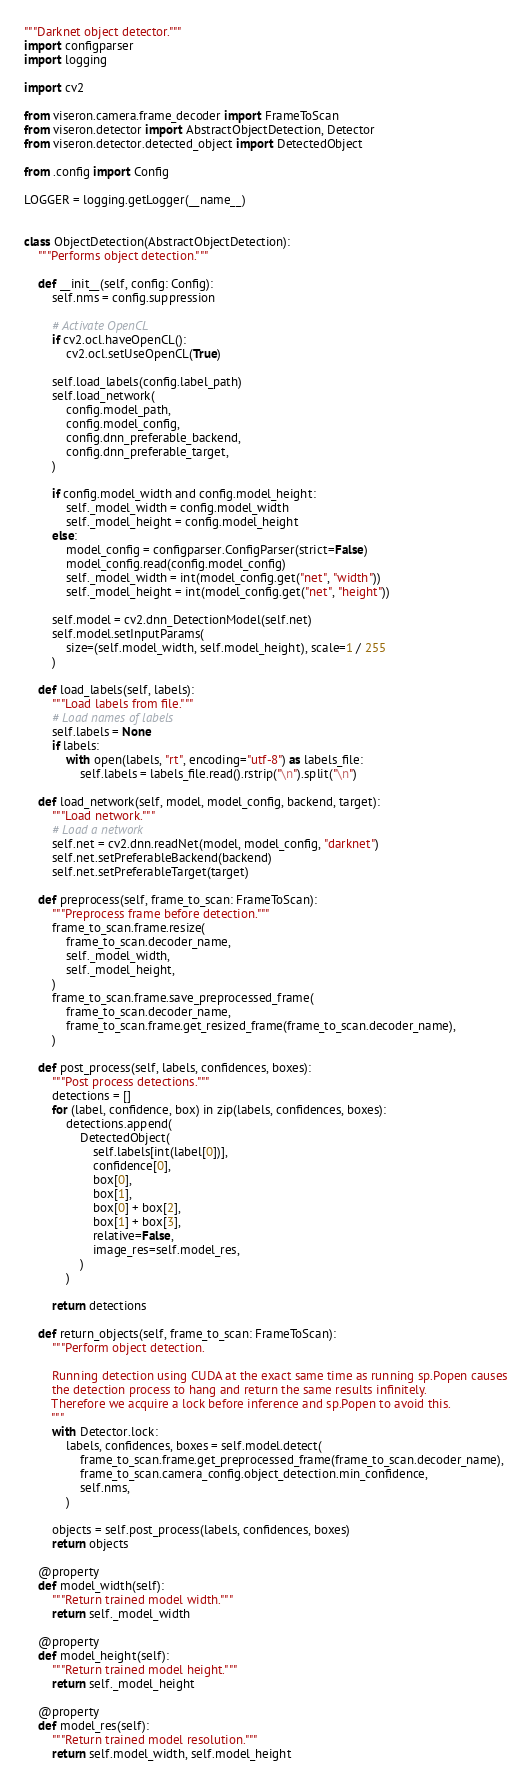Convert code to text. <code><loc_0><loc_0><loc_500><loc_500><_Python_>"""Darknet object detector."""
import configparser
import logging

import cv2

from viseron.camera.frame_decoder import FrameToScan
from viseron.detector import AbstractObjectDetection, Detector
from viseron.detector.detected_object import DetectedObject

from .config import Config

LOGGER = logging.getLogger(__name__)


class ObjectDetection(AbstractObjectDetection):
    """Performs object detection."""

    def __init__(self, config: Config):
        self.nms = config.suppression

        # Activate OpenCL
        if cv2.ocl.haveOpenCL():
            cv2.ocl.setUseOpenCL(True)

        self.load_labels(config.label_path)
        self.load_network(
            config.model_path,
            config.model_config,
            config.dnn_preferable_backend,
            config.dnn_preferable_target,
        )

        if config.model_width and config.model_height:
            self._model_width = config.model_width
            self._model_height = config.model_height
        else:
            model_config = configparser.ConfigParser(strict=False)
            model_config.read(config.model_config)
            self._model_width = int(model_config.get("net", "width"))
            self._model_height = int(model_config.get("net", "height"))

        self.model = cv2.dnn_DetectionModel(self.net)
        self.model.setInputParams(
            size=(self.model_width, self.model_height), scale=1 / 255
        )

    def load_labels(self, labels):
        """Load labels from file."""
        # Load names of labels
        self.labels = None
        if labels:
            with open(labels, "rt", encoding="utf-8") as labels_file:
                self.labels = labels_file.read().rstrip("\n").split("\n")

    def load_network(self, model, model_config, backend, target):
        """Load network."""
        # Load a network
        self.net = cv2.dnn.readNet(model, model_config, "darknet")
        self.net.setPreferableBackend(backend)
        self.net.setPreferableTarget(target)

    def preprocess(self, frame_to_scan: FrameToScan):
        """Preprocess frame before detection."""
        frame_to_scan.frame.resize(
            frame_to_scan.decoder_name,
            self._model_width,
            self._model_height,
        )
        frame_to_scan.frame.save_preprocessed_frame(
            frame_to_scan.decoder_name,
            frame_to_scan.frame.get_resized_frame(frame_to_scan.decoder_name),
        )

    def post_process(self, labels, confidences, boxes):
        """Post process detections."""
        detections = []
        for (label, confidence, box) in zip(labels, confidences, boxes):
            detections.append(
                DetectedObject(
                    self.labels[int(label[0])],
                    confidence[0],
                    box[0],
                    box[1],
                    box[0] + box[2],
                    box[1] + box[3],
                    relative=False,
                    image_res=self.model_res,
                )
            )

        return detections

    def return_objects(self, frame_to_scan: FrameToScan):
        """Perform object detection.

        Running detection using CUDA at the exact same time as running sp.Popen causes
        the detection process to hang and return the same results infinitely.
        Therefore we acquire a lock before inference and sp.Popen to avoid this.
        """
        with Detector.lock:
            labels, confidences, boxes = self.model.detect(
                frame_to_scan.frame.get_preprocessed_frame(frame_to_scan.decoder_name),
                frame_to_scan.camera_config.object_detection.min_confidence,
                self.nms,
            )

        objects = self.post_process(labels, confidences, boxes)
        return objects

    @property
    def model_width(self):
        """Return trained model width."""
        return self._model_width

    @property
    def model_height(self):
        """Return trained model height."""
        return self._model_height

    @property
    def model_res(self):
        """Return trained model resolution."""
        return self.model_width, self.model_height
</code> 